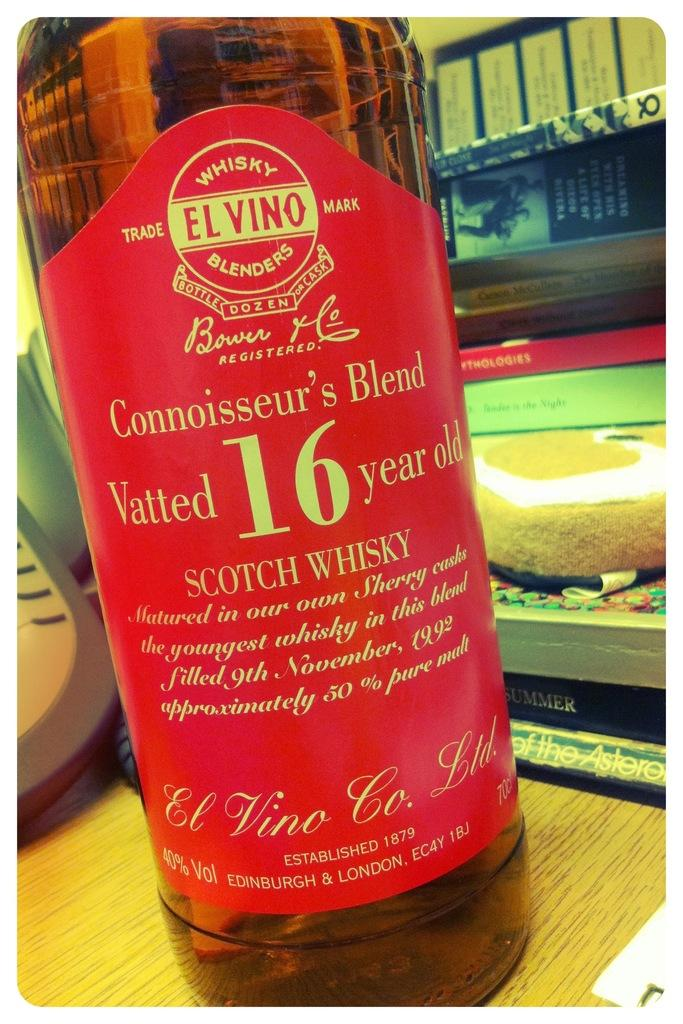<image>
Present a compact description of the photo's key features. The label on a bottle of scotch whisky declares that the whisky is 16 years old. 